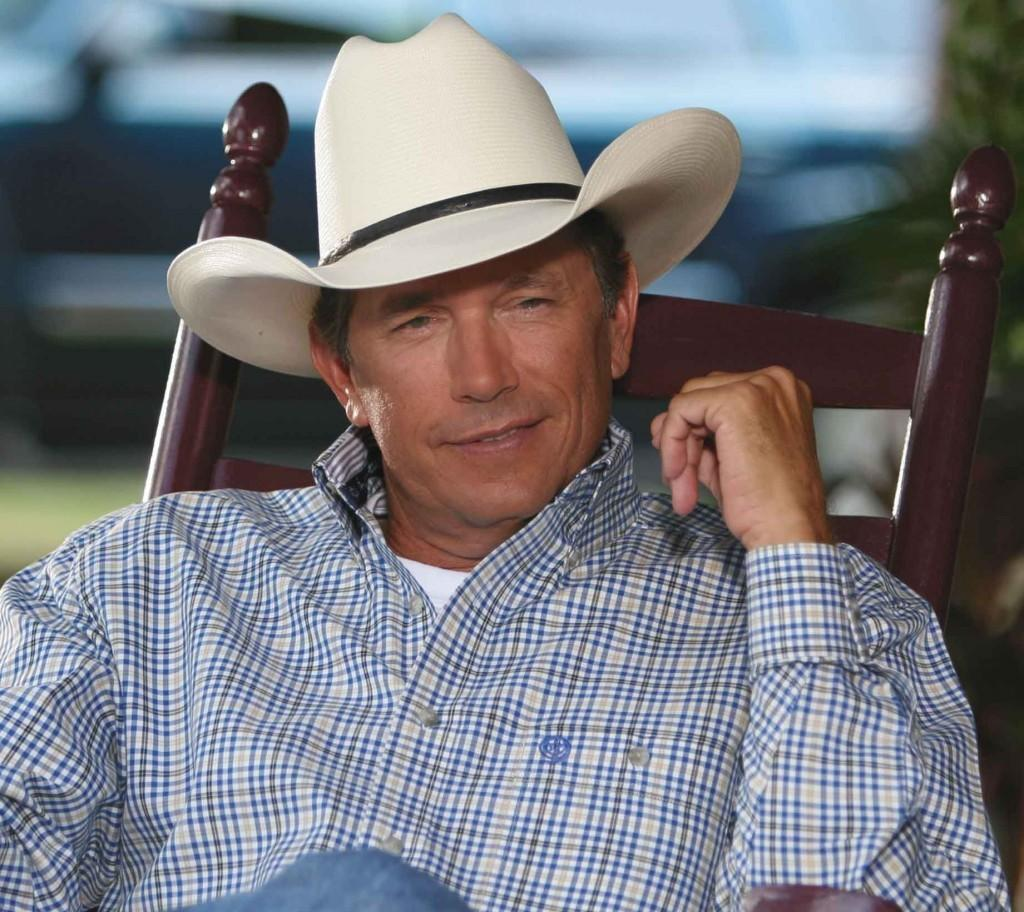Who is present in the image? There is a man in the image. What is the man doing in the image? The man is sitting on a chair. What is the man wearing on his head? The man is wearing a hat. What type of jam is the man eating in the image? There is no jam present in the image, and the man is not eating anything. 